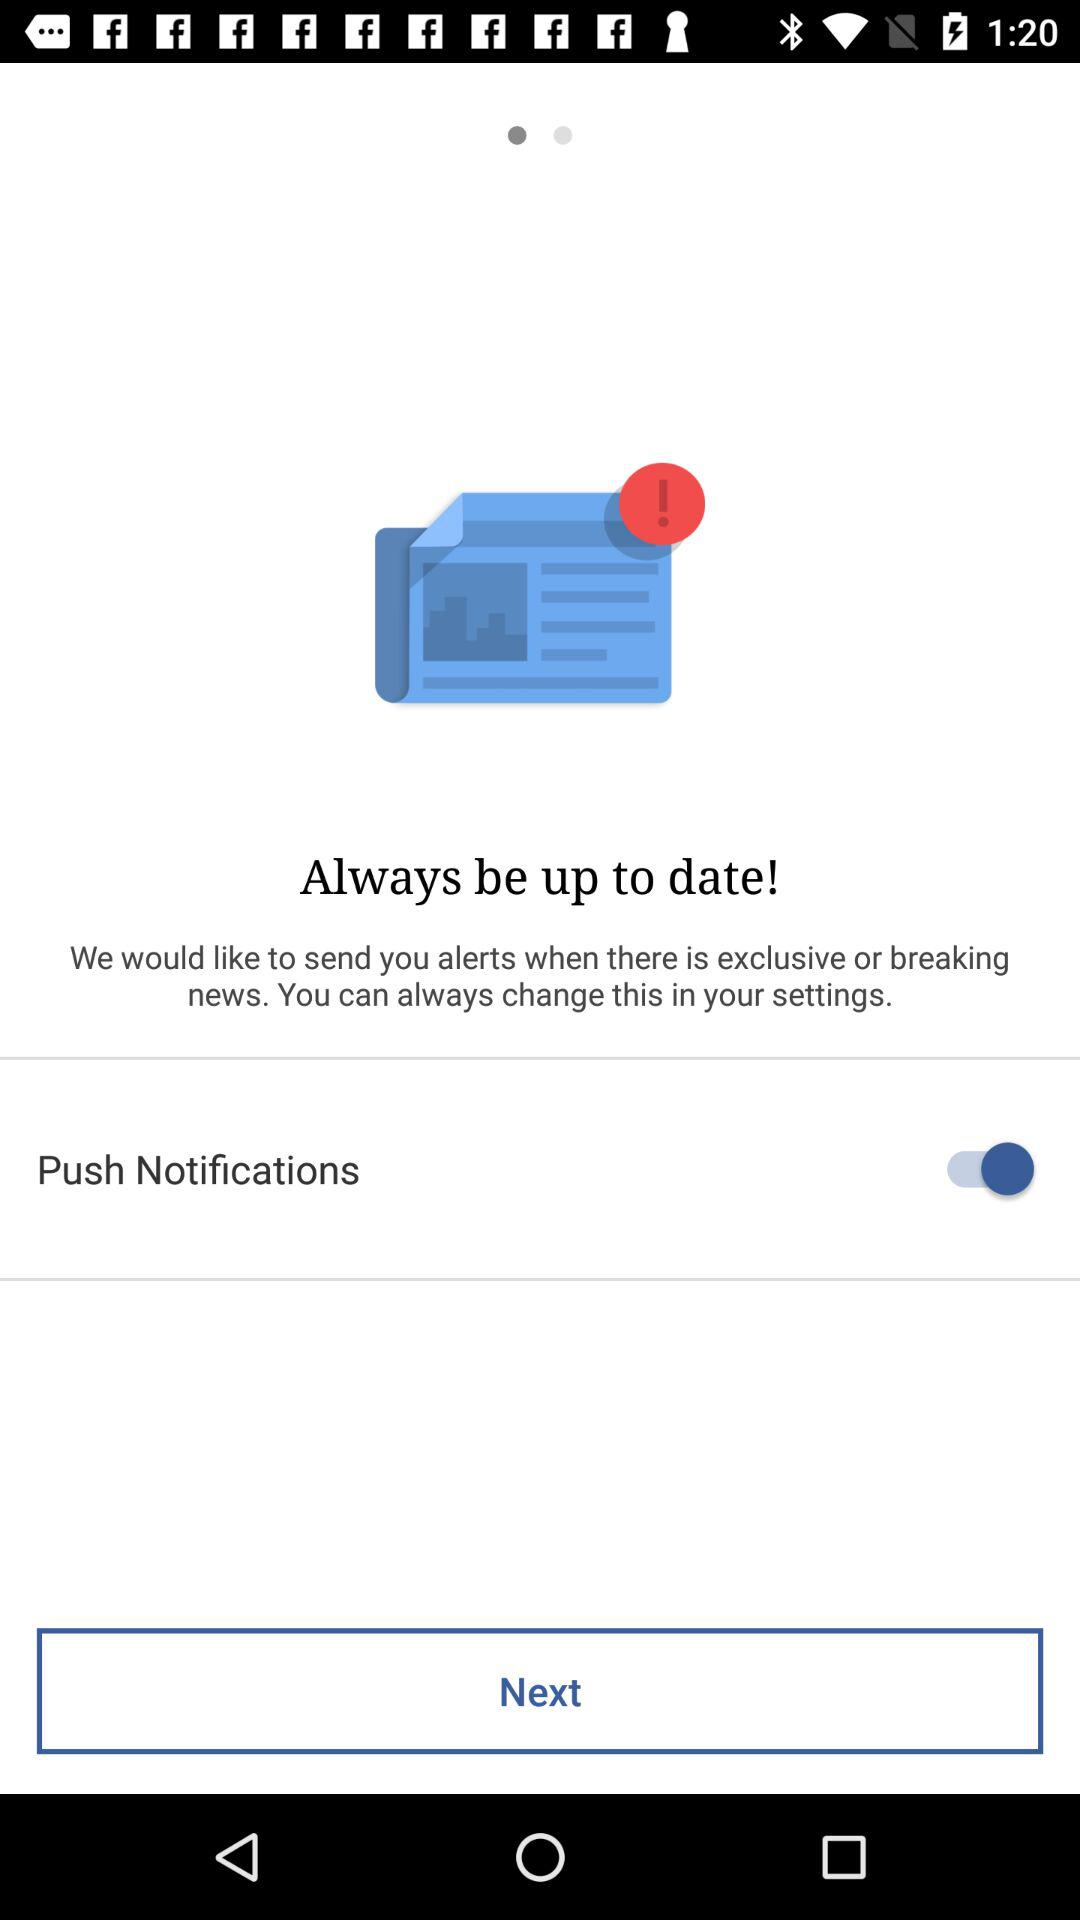What is the status of the "Push Notifications"? The status of the "Push Notifications" is "on". 